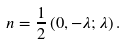Convert formula to latex. <formula><loc_0><loc_0><loc_500><loc_500>n = \frac { 1 } { 2 } \left ( 0 , - \lambda ; \lambda \right ) .</formula> 